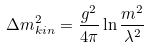Convert formula to latex. <formula><loc_0><loc_0><loc_500><loc_500>\Delta m ^ { 2 } _ { k i n } = \frac { g ^ { 2 } } { 4 \pi } \ln \frac { m ^ { 2 } } { \lambda ^ { 2 } }</formula> 